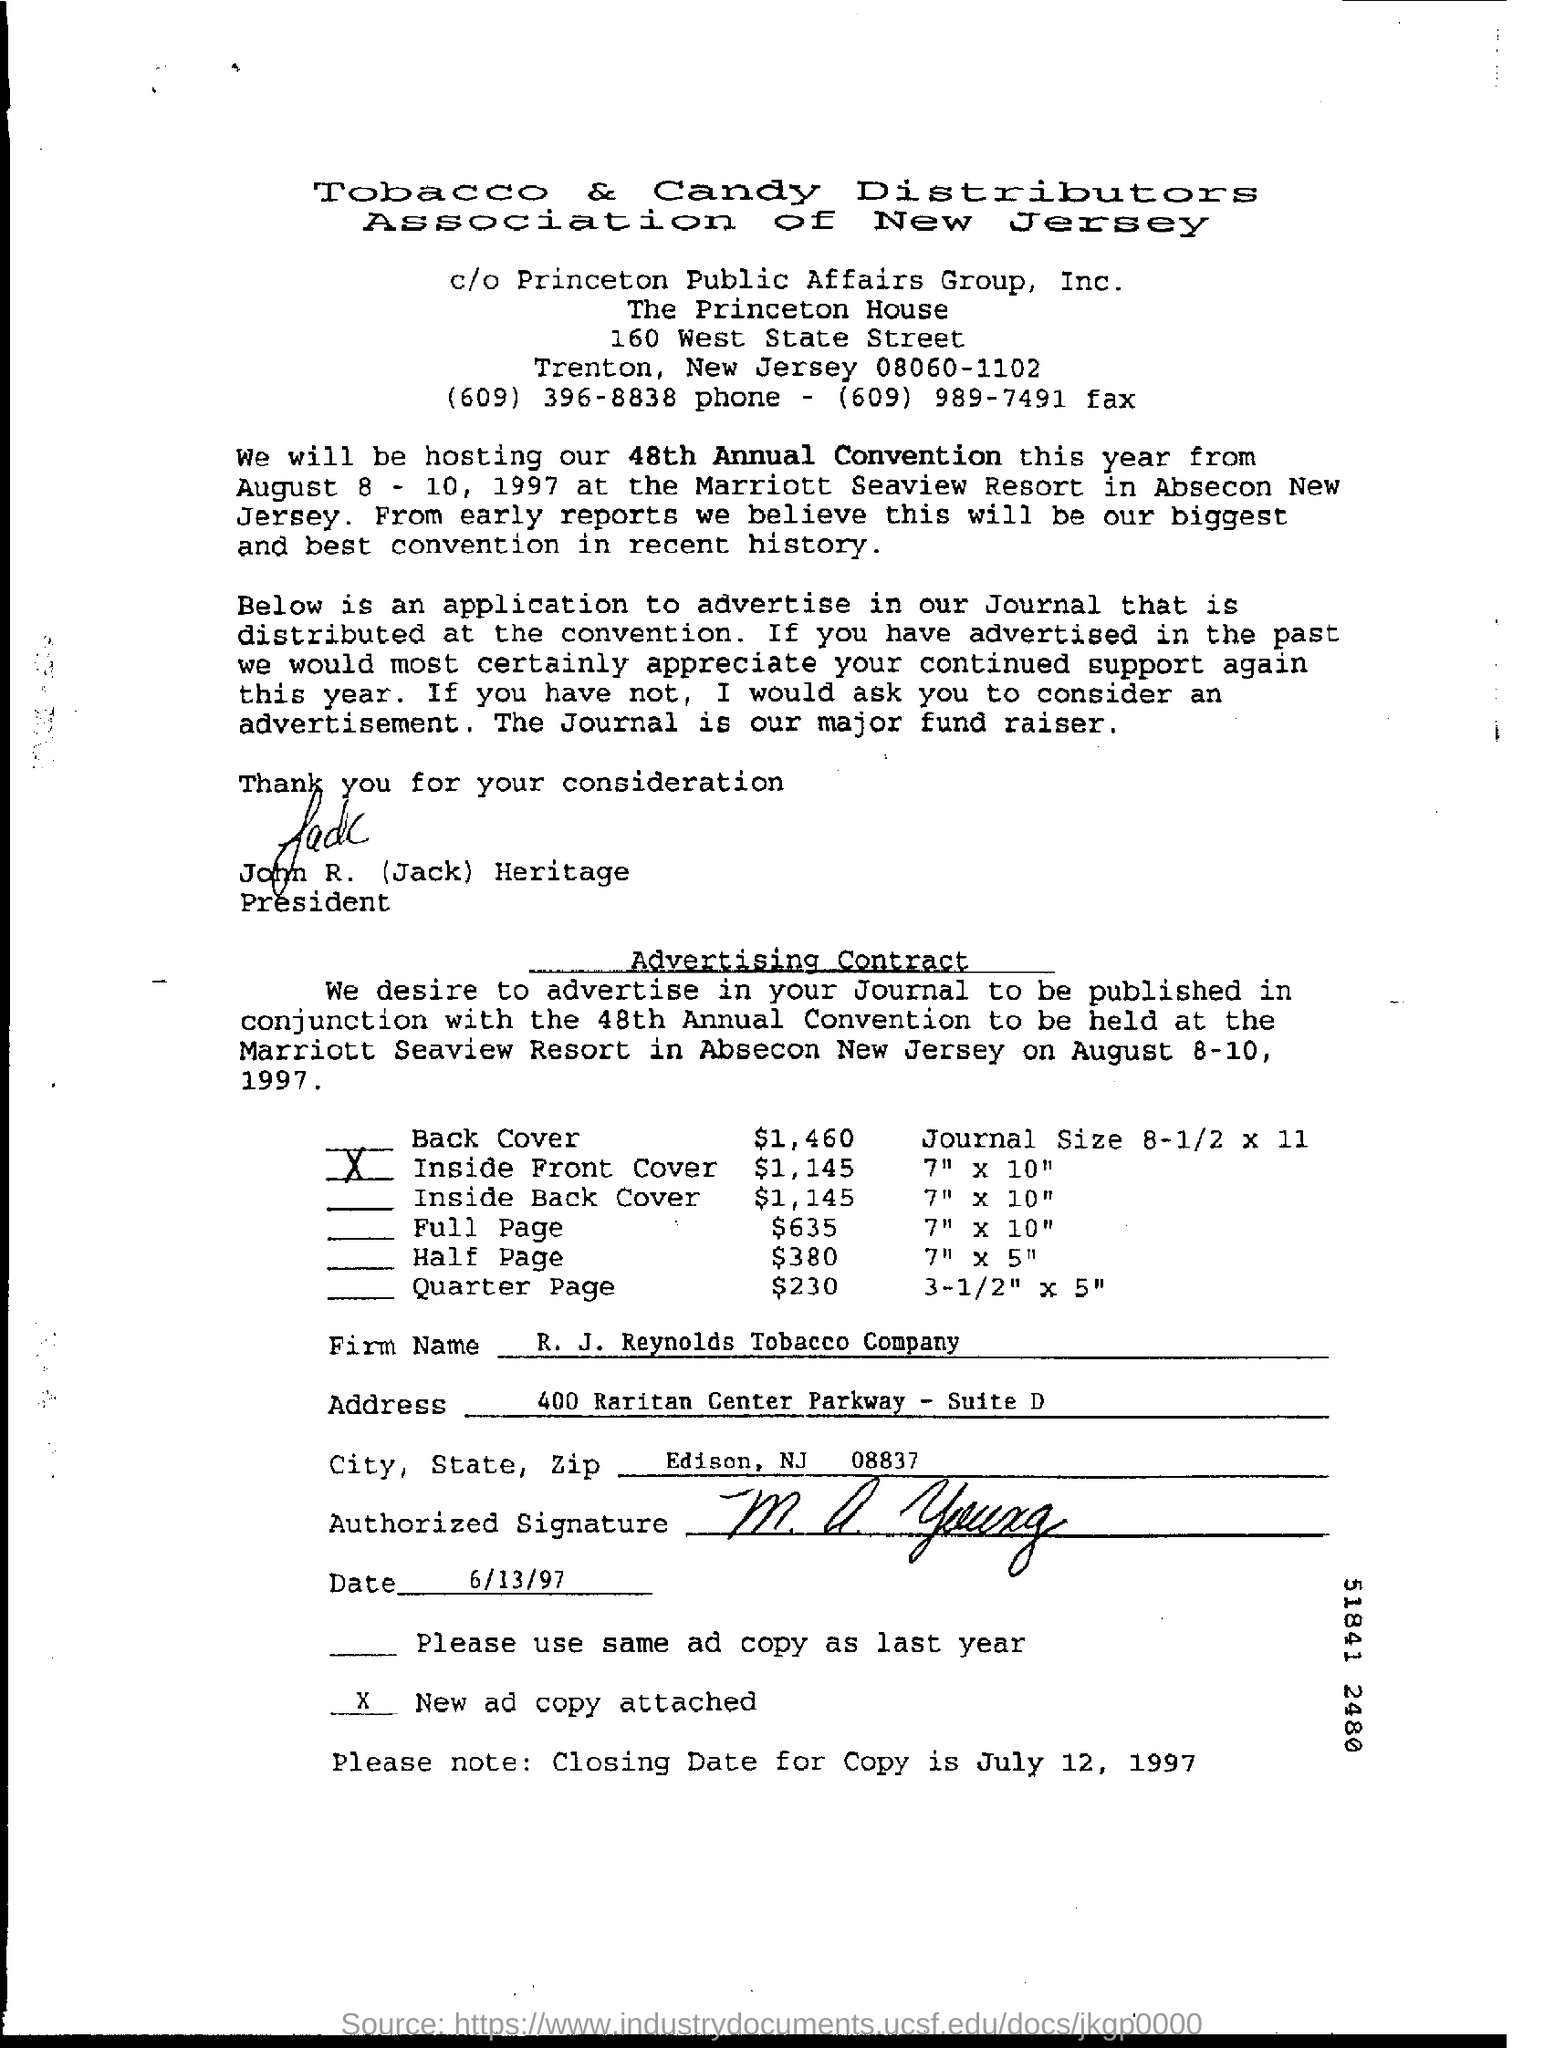Give some essential details in this illustration. The closing date for copying is July 12, 1997. The firm in question is R. J. Reynolds Tobacco Company. 